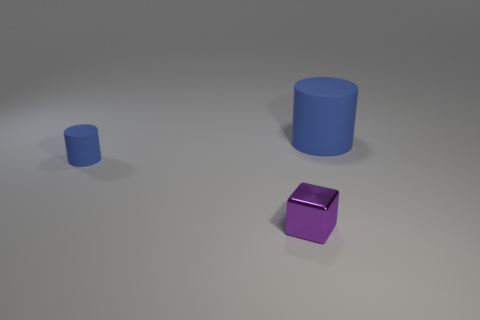Are there the same number of tiny purple shiny things to the left of the small block and small matte cylinders behind the big cylinder?
Keep it short and to the point. Yes. What number of purple metallic things are the same shape as the large matte object?
Keep it short and to the point. 0. Is there a large object?
Your answer should be very brief. Yes. Is the small block made of the same material as the thing left of the metal object?
Provide a short and direct response. No. What material is the thing that is the same size as the block?
Your response must be concise. Rubber. Are there any other large objects made of the same material as the big thing?
Your answer should be compact. No. Are there any purple blocks that are to the right of the matte thing that is in front of the matte thing right of the small blue cylinder?
Your response must be concise. Yes. There is a blue thing that is the same size as the purple thing; what is its shape?
Offer a terse response. Cylinder. There is a matte thing in front of the large matte thing; is its size the same as the blue cylinder to the right of the small blue cylinder?
Offer a terse response. No. How many big rubber objects are there?
Your response must be concise. 1. 